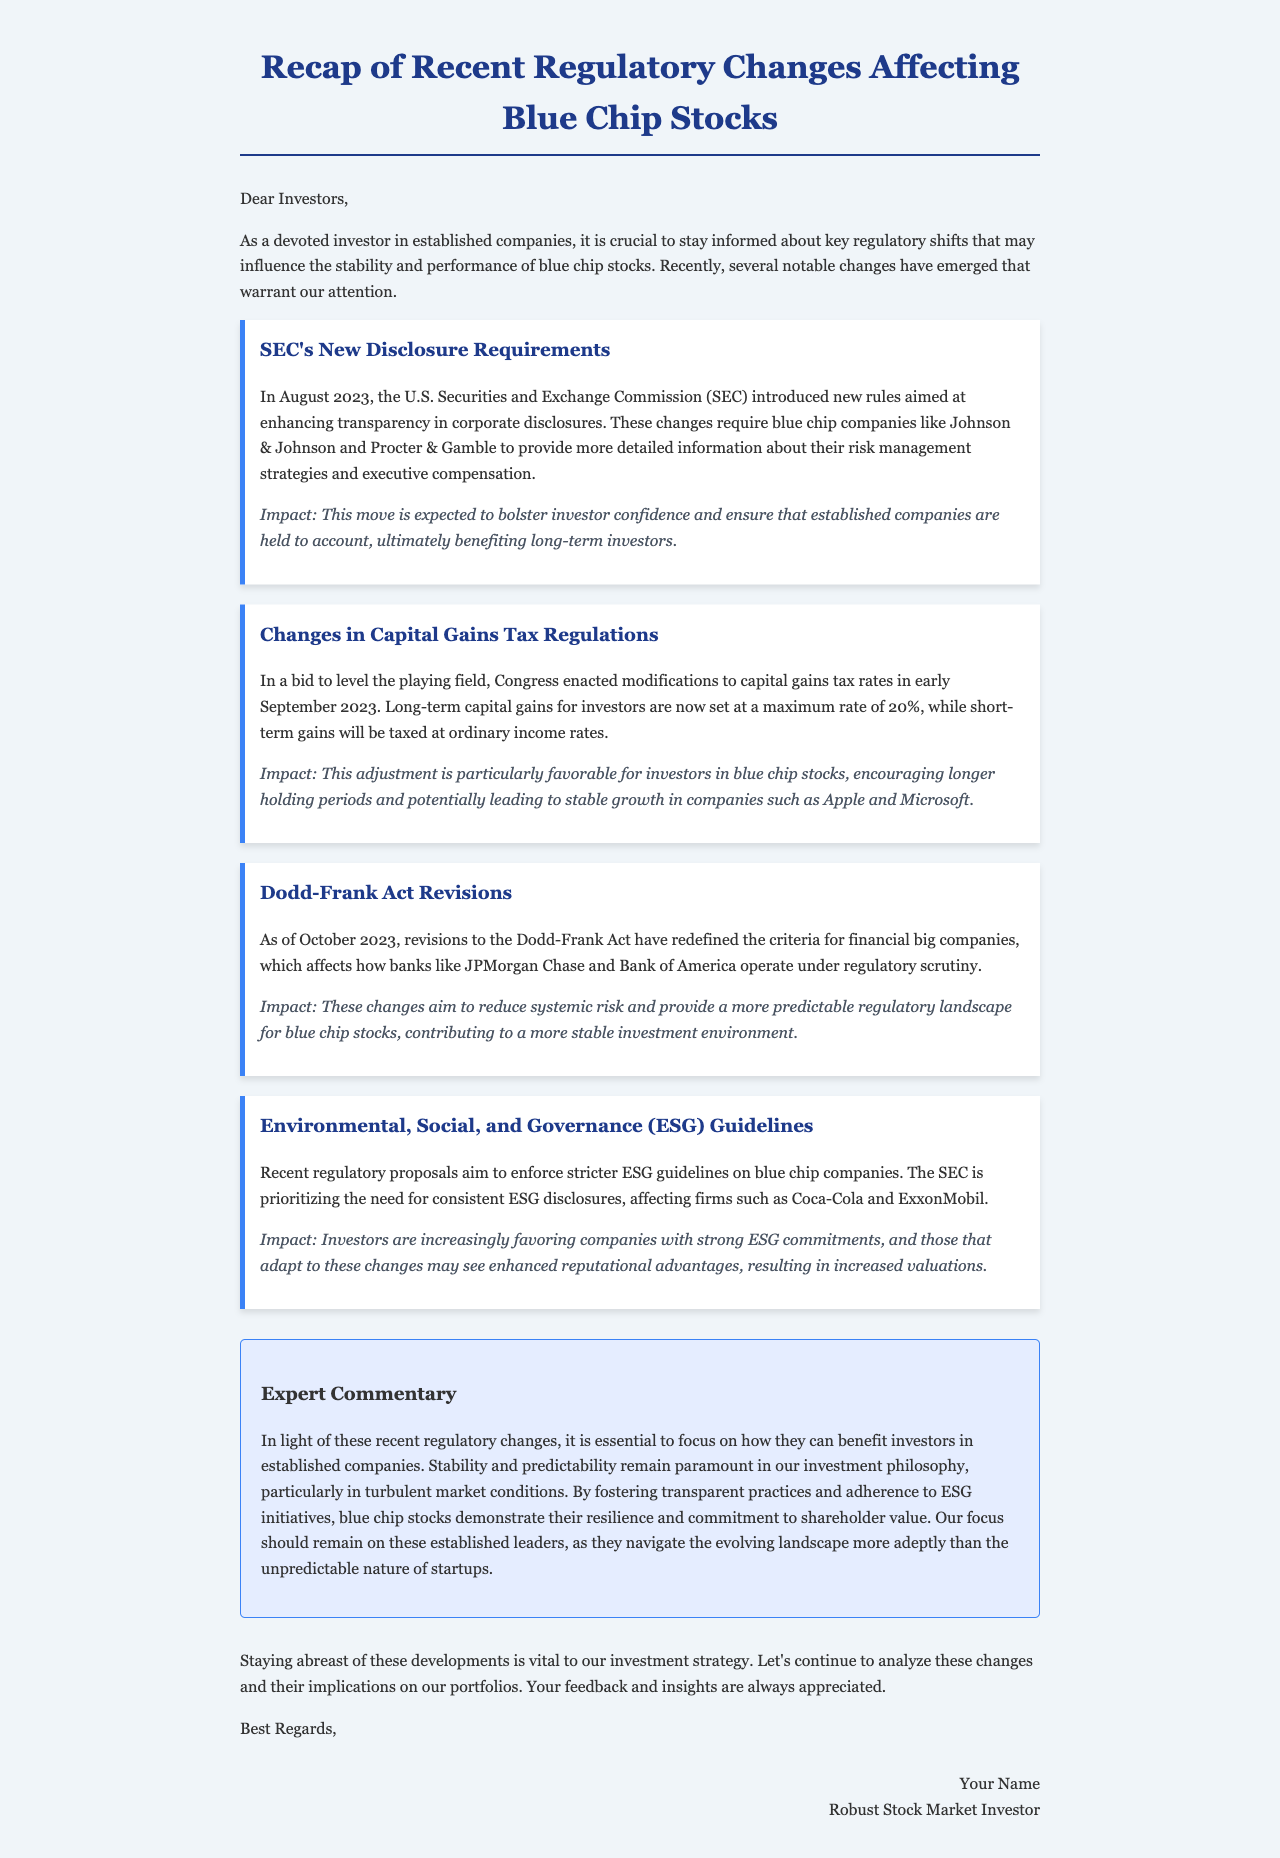What new rules did the SEC introduce in August 2023? The SEC introduced new rules aimed at enhancing transparency in corporate disclosures.
Answer: New disclosure requirements What is the maximum long-term capital gains tax rate set by Congress in September 2023? Congress set long-term capital gains for investors at a maximum rate of 20%.
Answer: 20% When were revisions to the Dodd-Frank Act enacted? The revisions to the Dodd-Frank Act were enacted as of October 2023.
Answer: October 2023 Which companies are specifically mentioned regarding stricter ESG guidelines? The companies mentioned are Coca-Cola and ExxonMobil.
Answer: Coca-Cola and ExxonMobil What is the impact of the new SEC rules on investor confidence? The move is expected to bolster investor confidence and ensure accountability.
Answer: Bolster investor confidence Why are the changes in capital gains tax beneficial for blue chip investors? The changes encourage longer holding periods and potentially stable growth.
Answer: Encourages longer holding periods What do the revisions to the Dodd-Frank Act aim to reduce? The revisions aim to reduce systemic risk.
Answer: Systemic risk What primary focus should remain for investors according to the expert commentary? The focus should remain on established leaders in the market.
Answer: Established leaders 